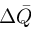Convert formula to latex. <formula><loc_0><loc_0><loc_500><loc_500>\Delta \bar { Q }</formula> 